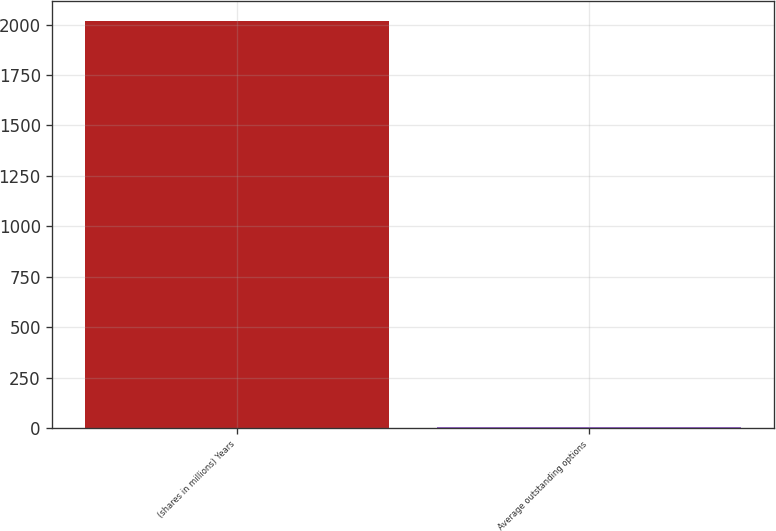<chart> <loc_0><loc_0><loc_500><loc_500><bar_chart><fcel>(shares in millions) Years<fcel>Average outstanding options<nl><fcel>2016<fcel>3.3<nl></chart> 